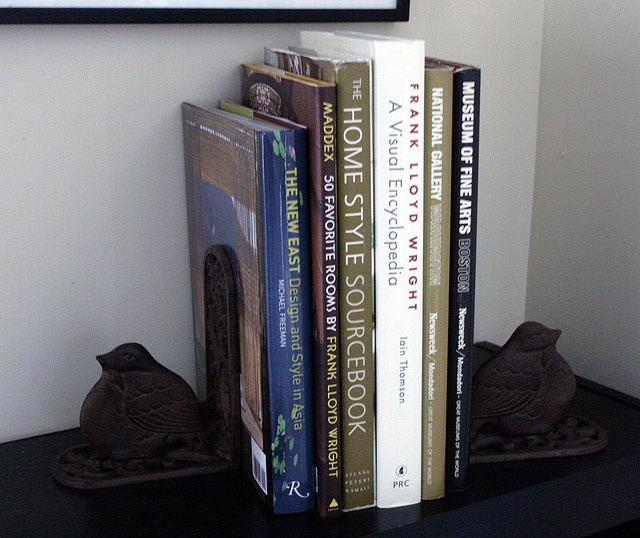Describe the objects in this image and their specific colors. I can see book in lavender, gray, black, navy, and darkblue tones, book in lavender, white, darkgray, and gray tones, book in lavender, gray, darkgreen, darkgray, and lightgray tones, book in lavender, black, gray, maroon, and purple tones, and book in lavender, black, darkgray, lightgray, and gray tones in this image. 